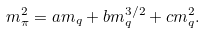Convert formula to latex. <formula><loc_0><loc_0><loc_500><loc_500>m _ { \pi } ^ { 2 } = a m _ { q } + b m _ { q } ^ { 3 / 2 } + c m _ { q } ^ { 2 } .</formula> 